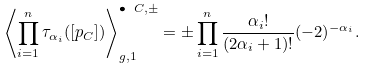Convert formula to latex. <formula><loc_0><loc_0><loc_500><loc_500>\left \langle \prod _ { i = 1 } ^ { n } \tau _ { \alpha _ { i } } ( [ p _ { C } ] ) \right \rangle _ { g , 1 } ^ { \bullet \ C , \pm } = \pm \prod _ { i = 1 } ^ { n } \frac { \alpha _ { i } ! } { ( 2 \alpha _ { i } + 1 ) ! } ( - 2 ) ^ { - \alpha _ { i } } .</formula> 